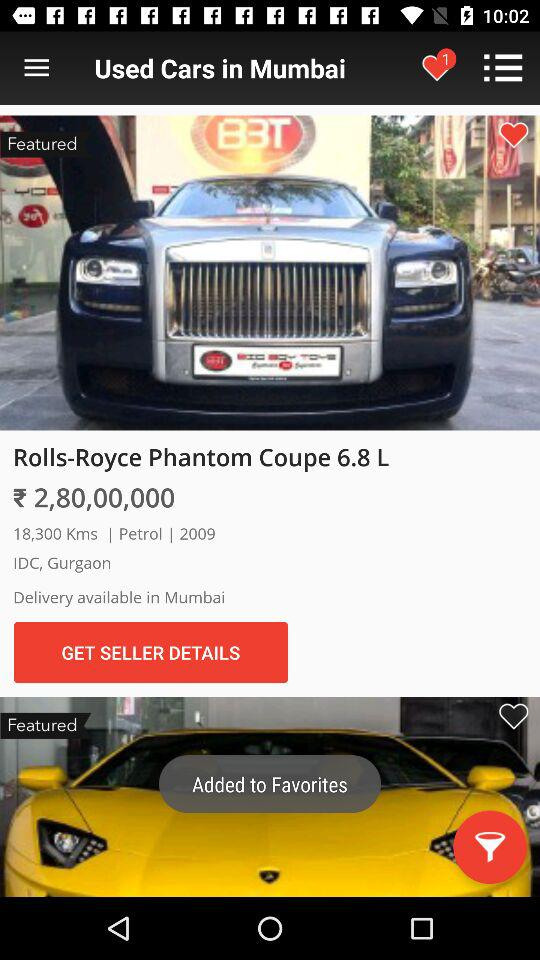In which city is the delivery available? The delivery is available in Mumbai. 